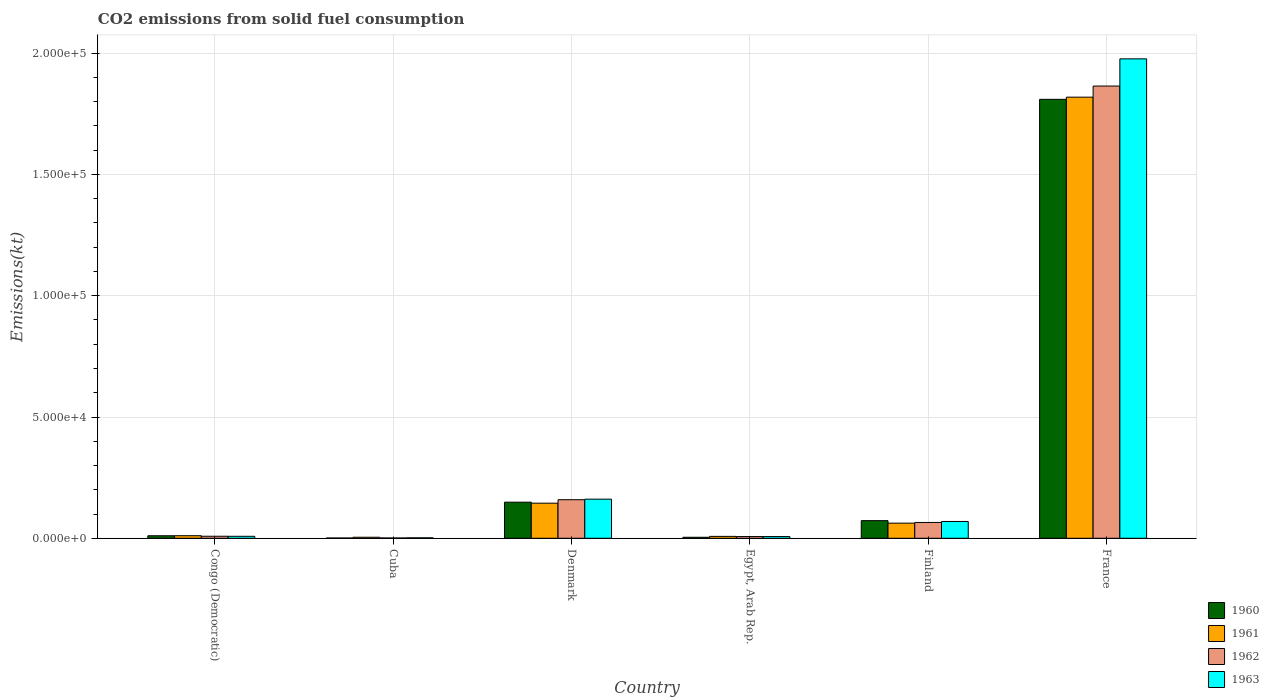How many different coloured bars are there?
Offer a very short reply. 4. How many groups of bars are there?
Give a very brief answer. 6. Are the number of bars per tick equal to the number of legend labels?
Your response must be concise. Yes. What is the amount of CO2 emitted in 1963 in France?
Your answer should be compact. 1.98e+05. Across all countries, what is the maximum amount of CO2 emitted in 1960?
Your answer should be very brief. 1.81e+05. Across all countries, what is the minimum amount of CO2 emitted in 1960?
Keep it short and to the point. 113.68. In which country was the amount of CO2 emitted in 1963 minimum?
Keep it short and to the point. Cuba. What is the total amount of CO2 emitted in 1960 in the graph?
Provide a succinct answer. 2.05e+05. What is the difference between the amount of CO2 emitted in 1963 in Cuba and that in Finland?
Your response must be concise. -6739.95. What is the difference between the amount of CO2 emitted in 1960 in France and the amount of CO2 emitted in 1961 in Finland?
Offer a terse response. 1.75e+05. What is the average amount of CO2 emitted in 1960 per country?
Keep it short and to the point. 3.41e+04. What is the difference between the amount of CO2 emitted of/in 1960 and amount of CO2 emitted of/in 1963 in Finland?
Your answer should be very brief. 341.03. In how many countries, is the amount of CO2 emitted in 1962 greater than 180000 kt?
Offer a terse response. 1. What is the ratio of the amount of CO2 emitted in 1961 in Finland to that in France?
Provide a short and direct response. 0.03. Is the difference between the amount of CO2 emitted in 1960 in Egypt, Arab Rep. and Finland greater than the difference between the amount of CO2 emitted in 1963 in Egypt, Arab Rep. and Finland?
Your answer should be very brief. No. What is the difference between the highest and the second highest amount of CO2 emitted in 1962?
Your response must be concise. 1.80e+05. What is the difference between the highest and the lowest amount of CO2 emitted in 1963?
Your response must be concise. 1.97e+05. Is the sum of the amount of CO2 emitted in 1960 in Egypt, Arab Rep. and Finland greater than the maximum amount of CO2 emitted in 1961 across all countries?
Ensure brevity in your answer.  No. Is it the case that in every country, the sum of the amount of CO2 emitted in 1961 and amount of CO2 emitted in 1962 is greater than the sum of amount of CO2 emitted in 1960 and amount of CO2 emitted in 1963?
Ensure brevity in your answer.  No. Is it the case that in every country, the sum of the amount of CO2 emitted in 1961 and amount of CO2 emitted in 1963 is greater than the amount of CO2 emitted in 1962?
Your answer should be compact. Yes. How many bars are there?
Keep it short and to the point. 24. Are all the bars in the graph horizontal?
Give a very brief answer. No. How many countries are there in the graph?
Your response must be concise. 6. What is the difference between two consecutive major ticks on the Y-axis?
Offer a very short reply. 5.00e+04. Are the values on the major ticks of Y-axis written in scientific E-notation?
Give a very brief answer. Yes. Where does the legend appear in the graph?
Provide a succinct answer. Bottom right. How many legend labels are there?
Ensure brevity in your answer.  4. What is the title of the graph?
Provide a short and direct response. CO2 emissions from solid fuel consumption. Does "2008" appear as one of the legend labels in the graph?
Keep it short and to the point. No. What is the label or title of the X-axis?
Make the answer very short. Country. What is the label or title of the Y-axis?
Keep it short and to the point. Emissions(kt). What is the Emissions(kt) of 1960 in Congo (Democratic)?
Provide a succinct answer. 1041.43. What is the Emissions(kt) in 1961 in Congo (Democratic)?
Provide a short and direct response. 1059.76. What is the Emissions(kt) of 1962 in Congo (Democratic)?
Make the answer very short. 839.74. What is the Emissions(kt) in 1963 in Congo (Democratic)?
Your response must be concise. 817.74. What is the Emissions(kt) in 1960 in Cuba?
Your answer should be very brief. 113.68. What is the Emissions(kt) of 1961 in Cuba?
Your answer should be very brief. 425.37. What is the Emissions(kt) of 1962 in Cuba?
Provide a short and direct response. 124.68. What is the Emissions(kt) in 1963 in Cuba?
Your answer should be compact. 187.02. What is the Emissions(kt) in 1960 in Denmark?
Give a very brief answer. 1.49e+04. What is the Emissions(kt) in 1961 in Denmark?
Provide a succinct answer. 1.45e+04. What is the Emissions(kt) in 1962 in Denmark?
Provide a short and direct response. 1.59e+04. What is the Emissions(kt) of 1963 in Denmark?
Keep it short and to the point. 1.61e+04. What is the Emissions(kt) in 1960 in Egypt, Arab Rep.?
Your answer should be compact. 414.37. What is the Emissions(kt) of 1961 in Egypt, Arab Rep.?
Make the answer very short. 781.07. What is the Emissions(kt) in 1962 in Egypt, Arab Rep.?
Keep it short and to the point. 707.73. What is the Emissions(kt) of 1963 in Egypt, Arab Rep.?
Provide a succinct answer. 707.73. What is the Emissions(kt) of 1960 in Finland?
Your answer should be very brief. 7267.99. What is the Emissions(kt) in 1961 in Finland?
Your response must be concise. 6237.57. What is the Emissions(kt) of 1962 in Finland?
Your answer should be very brief. 6523.59. What is the Emissions(kt) in 1963 in Finland?
Offer a terse response. 6926.96. What is the Emissions(kt) in 1960 in France?
Your response must be concise. 1.81e+05. What is the Emissions(kt) in 1961 in France?
Offer a terse response. 1.82e+05. What is the Emissions(kt) of 1962 in France?
Your answer should be very brief. 1.86e+05. What is the Emissions(kt) of 1963 in France?
Keep it short and to the point. 1.98e+05. Across all countries, what is the maximum Emissions(kt) in 1960?
Provide a short and direct response. 1.81e+05. Across all countries, what is the maximum Emissions(kt) in 1961?
Your answer should be very brief. 1.82e+05. Across all countries, what is the maximum Emissions(kt) of 1962?
Offer a terse response. 1.86e+05. Across all countries, what is the maximum Emissions(kt) in 1963?
Make the answer very short. 1.98e+05. Across all countries, what is the minimum Emissions(kt) of 1960?
Your answer should be very brief. 113.68. Across all countries, what is the minimum Emissions(kt) of 1961?
Provide a short and direct response. 425.37. Across all countries, what is the minimum Emissions(kt) in 1962?
Provide a short and direct response. 124.68. Across all countries, what is the minimum Emissions(kt) of 1963?
Provide a short and direct response. 187.02. What is the total Emissions(kt) in 1960 in the graph?
Provide a succinct answer. 2.05e+05. What is the total Emissions(kt) of 1961 in the graph?
Ensure brevity in your answer.  2.05e+05. What is the total Emissions(kt) of 1962 in the graph?
Your response must be concise. 2.11e+05. What is the total Emissions(kt) of 1963 in the graph?
Offer a very short reply. 2.22e+05. What is the difference between the Emissions(kt) of 1960 in Congo (Democratic) and that in Cuba?
Give a very brief answer. 927.75. What is the difference between the Emissions(kt) in 1961 in Congo (Democratic) and that in Cuba?
Your answer should be very brief. 634.39. What is the difference between the Emissions(kt) of 1962 in Congo (Democratic) and that in Cuba?
Offer a terse response. 715.07. What is the difference between the Emissions(kt) of 1963 in Congo (Democratic) and that in Cuba?
Give a very brief answer. 630.72. What is the difference between the Emissions(kt) in 1960 in Congo (Democratic) and that in Denmark?
Offer a terse response. -1.38e+04. What is the difference between the Emissions(kt) in 1961 in Congo (Democratic) and that in Denmark?
Your answer should be very brief. -1.34e+04. What is the difference between the Emissions(kt) of 1962 in Congo (Democratic) and that in Denmark?
Ensure brevity in your answer.  -1.51e+04. What is the difference between the Emissions(kt) in 1963 in Congo (Democratic) and that in Denmark?
Provide a succinct answer. -1.53e+04. What is the difference between the Emissions(kt) of 1960 in Congo (Democratic) and that in Egypt, Arab Rep.?
Offer a very short reply. 627.06. What is the difference between the Emissions(kt) of 1961 in Congo (Democratic) and that in Egypt, Arab Rep.?
Your response must be concise. 278.69. What is the difference between the Emissions(kt) in 1962 in Congo (Democratic) and that in Egypt, Arab Rep.?
Your answer should be compact. 132.01. What is the difference between the Emissions(kt) in 1963 in Congo (Democratic) and that in Egypt, Arab Rep.?
Your response must be concise. 110.01. What is the difference between the Emissions(kt) of 1960 in Congo (Democratic) and that in Finland?
Your response must be concise. -6226.57. What is the difference between the Emissions(kt) in 1961 in Congo (Democratic) and that in Finland?
Offer a terse response. -5177.8. What is the difference between the Emissions(kt) of 1962 in Congo (Democratic) and that in Finland?
Offer a terse response. -5683.85. What is the difference between the Emissions(kt) in 1963 in Congo (Democratic) and that in Finland?
Offer a terse response. -6109.22. What is the difference between the Emissions(kt) of 1960 in Congo (Democratic) and that in France?
Give a very brief answer. -1.80e+05. What is the difference between the Emissions(kt) of 1961 in Congo (Democratic) and that in France?
Provide a short and direct response. -1.81e+05. What is the difference between the Emissions(kt) of 1962 in Congo (Democratic) and that in France?
Keep it short and to the point. -1.86e+05. What is the difference between the Emissions(kt) in 1963 in Congo (Democratic) and that in France?
Ensure brevity in your answer.  -1.97e+05. What is the difference between the Emissions(kt) in 1960 in Cuba and that in Denmark?
Give a very brief answer. -1.48e+04. What is the difference between the Emissions(kt) in 1961 in Cuba and that in Denmark?
Your response must be concise. -1.40e+04. What is the difference between the Emissions(kt) in 1962 in Cuba and that in Denmark?
Offer a very short reply. -1.58e+04. What is the difference between the Emissions(kt) of 1963 in Cuba and that in Denmark?
Your answer should be very brief. -1.59e+04. What is the difference between the Emissions(kt) in 1960 in Cuba and that in Egypt, Arab Rep.?
Ensure brevity in your answer.  -300.69. What is the difference between the Emissions(kt) in 1961 in Cuba and that in Egypt, Arab Rep.?
Offer a very short reply. -355.7. What is the difference between the Emissions(kt) in 1962 in Cuba and that in Egypt, Arab Rep.?
Ensure brevity in your answer.  -583.05. What is the difference between the Emissions(kt) of 1963 in Cuba and that in Egypt, Arab Rep.?
Give a very brief answer. -520.71. What is the difference between the Emissions(kt) of 1960 in Cuba and that in Finland?
Ensure brevity in your answer.  -7154.32. What is the difference between the Emissions(kt) in 1961 in Cuba and that in Finland?
Make the answer very short. -5812.19. What is the difference between the Emissions(kt) of 1962 in Cuba and that in Finland?
Your answer should be compact. -6398.91. What is the difference between the Emissions(kt) in 1963 in Cuba and that in Finland?
Give a very brief answer. -6739.95. What is the difference between the Emissions(kt) in 1960 in Cuba and that in France?
Keep it short and to the point. -1.81e+05. What is the difference between the Emissions(kt) in 1961 in Cuba and that in France?
Offer a terse response. -1.81e+05. What is the difference between the Emissions(kt) of 1962 in Cuba and that in France?
Keep it short and to the point. -1.86e+05. What is the difference between the Emissions(kt) in 1963 in Cuba and that in France?
Your response must be concise. -1.97e+05. What is the difference between the Emissions(kt) of 1960 in Denmark and that in Egypt, Arab Rep.?
Keep it short and to the point. 1.45e+04. What is the difference between the Emissions(kt) of 1961 in Denmark and that in Egypt, Arab Rep.?
Your response must be concise. 1.37e+04. What is the difference between the Emissions(kt) in 1962 in Denmark and that in Egypt, Arab Rep.?
Make the answer very short. 1.52e+04. What is the difference between the Emissions(kt) of 1963 in Denmark and that in Egypt, Arab Rep.?
Offer a terse response. 1.54e+04. What is the difference between the Emissions(kt) in 1960 in Denmark and that in Finland?
Offer a terse response. 7620.03. What is the difference between the Emissions(kt) of 1961 in Denmark and that in Finland?
Provide a succinct answer. 8232.42. What is the difference between the Emissions(kt) in 1962 in Denmark and that in Finland?
Keep it short and to the point. 9380.19. What is the difference between the Emissions(kt) of 1963 in Denmark and that in Finland?
Make the answer very short. 9204.17. What is the difference between the Emissions(kt) of 1960 in Denmark and that in France?
Provide a succinct answer. -1.66e+05. What is the difference between the Emissions(kt) in 1961 in Denmark and that in France?
Make the answer very short. -1.67e+05. What is the difference between the Emissions(kt) in 1962 in Denmark and that in France?
Offer a very short reply. -1.71e+05. What is the difference between the Emissions(kt) in 1963 in Denmark and that in France?
Your response must be concise. -1.82e+05. What is the difference between the Emissions(kt) of 1960 in Egypt, Arab Rep. and that in Finland?
Offer a very short reply. -6853.62. What is the difference between the Emissions(kt) of 1961 in Egypt, Arab Rep. and that in Finland?
Your answer should be compact. -5456.5. What is the difference between the Emissions(kt) of 1962 in Egypt, Arab Rep. and that in Finland?
Offer a very short reply. -5815.86. What is the difference between the Emissions(kt) of 1963 in Egypt, Arab Rep. and that in Finland?
Give a very brief answer. -6219.23. What is the difference between the Emissions(kt) in 1960 in Egypt, Arab Rep. and that in France?
Your answer should be compact. -1.81e+05. What is the difference between the Emissions(kt) of 1961 in Egypt, Arab Rep. and that in France?
Offer a terse response. -1.81e+05. What is the difference between the Emissions(kt) in 1962 in Egypt, Arab Rep. and that in France?
Give a very brief answer. -1.86e+05. What is the difference between the Emissions(kt) in 1963 in Egypt, Arab Rep. and that in France?
Make the answer very short. -1.97e+05. What is the difference between the Emissions(kt) in 1960 in Finland and that in France?
Your answer should be very brief. -1.74e+05. What is the difference between the Emissions(kt) of 1961 in Finland and that in France?
Offer a terse response. -1.76e+05. What is the difference between the Emissions(kt) in 1962 in Finland and that in France?
Make the answer very short. -1.80e+05. What is the difference between the Emissions(kt) in 1963 in Finland and that in France?
Offer a very short reply. -1.91e+05. What is the difference between the Emissions(kt) in 1960 in Congo (Democratic) and the Emissions(kt) in 1961 in Cuba?
Keep it short and to the point. 616.06. What is the difference between the Emissions(kt) in 1960 in Congo (Democratic) and the Emissions(kt) in 1962 in Cuba?
Ensure brevity in your answer.  916.75. What is the difference between the Emissions(kt) of 1960 in Congo (Democratic) and the Emissions(kt) of 1963 in Cuba?
Ensure brevity in your answer.  854.41. What is the difference between the Emissions(kt) in 1961 in Congo (Democratic) and the Emissions(kt) in 1962 in Cuba?
Keep it short and to the point. 935.09. What is the difference between the Emissions(kt) in 1961 in Congo (Democratic) and the Emissions(kt) in 1963 in Cuba?
Provide a succinct answer. 872.75. What is the difference between the Emissions(kt) of 1962 in Congo (Democratic) and the Emissions(kt) of 1963 in Cuba?
Your response must be concise. 652.73. What is the difference between the Emissions(kt) of 1960 in Congo (Democratic) and the Emissions(kt) of 1961 in Denmark?
Make the answer very short. -1.34e+04. What is the difference between the Emissions(kt) in 1960 in Congo (Democratic) and the Emissions(kt) in 1962 in Denmark?
Provide a short and direct response. -1.49e+04. What is the difference between the Emissions(kt) in 1960 in Congo (Democratic) and the Emissions(kt) in 1963 in Denmark?
Keep it short and to the point. -1.51e+04. What is the difference between the Emissions(kt) in 1961 in Congo (Democratic) and the Emissions(kt) in 1962 in Denmark?
Offer a very short reply. -1.48e+04. What is the difference between the Emissions(kt) of 1961 in Congo (Democratic) and the Emissions(kt) of 1963 in Denmark?
Provide a succinct answer. -1.51e+04. What is the difference between the Emissions(kt) in 1962 in Congo (Democratic) and the Emissions(kt) in 1963 in Denmark?
Make the answer very short. -1.53e+04. What is the difference between the Emissions(kt) of 1960 in Congo (Democratic) and the Emissions(kt) of 1961 in Egypt, Arab Rep.?
Provide a short and direct response. 260.36. What is the difference between the Emissions(kt) in 1960 in Congo (Democratic) and the Emissions(kt) in 1962 in Egypt, Arab Rep.?
Offer a terse response. 333.7. What is the difference between the Emissions(kt) of 1960 in Congo (Democratic) and the Emissions(kt) of 1963 in Egypt, Arab Rep.?
Your answer should be compact. 333.7. What is the difference between the Emissions(kt) of 1961 in Congo (Democratic) and the Emissions(kt) of 1962 in Egypt, Arab Rep.?
Your answer should be very brief. 352.03. What is the difference between the Emissions(kt) in 1961 in Congo (Democratic) and the Emissions(kt) in 1963 in Egypt, Arab Rep.?
Give a very brief answer. 352.03. What is the difference between the Emissions(kt) of 1962 in Congo (Democratic) and the Emissions(kt) of 1963 in Egypt, Arab Rep.?
Keep it short and to the point. 132.01. What is the difference between the Emissions(kt) in 1960 in Congo (Democratic) and the Emissions(kt) in 1961 in Finland?
Provide a short and direct response. -5196.14. What is the difference between the Emissions(kt) in 1960 in Congo (Democratic) and the Emissions(kt) in 1962 in Finland?
Offer a terse response. -5482.16. What is the difference between the Emissions(kt) of 1960 in Congo (Democratic) and the Emissions(kt) of 1963 in Finland?
Your answer should be very brief. -5885.53. What is the difference between the Emissions(kt) in 1961 in Congo (Democratic) and the Emissions(kt) in 1962 in Finland?
Give a very brief answer. -5463.83. What is the difference between the Emissions(kt) of 1961 in Congo (Democratic) and the Emissions(kt) of 1963 in Finland?
Give a very brief answer. -5867.2. What is the difference between the Emissions(kt) of 1962 in Congo (Democratic) and the Emissions(kt) of 1963 in Finland?
Provide a short and direct response. -6087.22. What is the difference between the Emissions(kt) of 1960 in Congo (Democratic) and the Emissions(kt) of 1961 in France?
Keep it short and to the point. -1.81e+05. What is the difference between the Emissions(kt) of 1960 in Congo (Democratic) and the Emissions(kt) of 1962 in France?
Keep it short and to the point. -1.85e+05. What is the difference between the Emissions(kt) of 1960 in Congo (Democratic) and the Emissions(kt) of 1963 in France?
Make the answer very short. -1.97e+05. What is the difference between the Emissions(kt) of 1961 in Congo (Democratic) and the Emissions(kt) of 1962 in France?
Your response must be concise. -1.85e+05. What is the difference between the Emissions(kt) of 1961 in Congo (Democratic) and the Emissions(kt) of 1963 in France?
Your answer should be compact. -1.97e+05. What is the difference between the Emissions(kt) in 1962 in Congo (Democratic) and the Emissions(kt) in 1963 in France?
Provide a succinct answer. -1.97e+05. What is the difference between the Emissions(kt) in 1960 in Cuba and the Emissions(kt) in 1961 in Denmark?
Offer a very short reply. -1.44e+04. What is the difference between the Emissions(kt) in 1960 in Cuba and the Emissions(kt) in 1962 in Denmark?
Give a very brief answer. -1.58e+04. What is the difference between the Emissions(kt) in 1960 in Cuba and the Emissions(kt) in 1963 in Denmark?
Your response must be concise. -1.60e+04. What is the difference between the Emissions(kt) in 1961 in Cuba and the Emissions(kt) in 1962 in Denmark?
Make the answer very short. -1.55e+04. What is the difference between the Emissions(kt) of 1961 in Cuba and the Emissions(kt) of 1963 in Denmark?
Offer a very short reply. -1.57e+04. What is the difference between the Emissions(kt) in 1962 in Cuba and the Emissions(kt) in 1963 in Denmark?
Give a very brief answer. -1.60e+04. What is the difference between the Emissions(kt) of 1960 in Cuba and the Emissions(kt) of 1961 in Egypt, Arab Rep.?
Your answer should be very brief. -667.39. What is the difference between the Emissions(kt) of 1960 in Cuba and the Emissions(kt) of 1962 in Egypt, Arab Rep.?
Your answer should be compact. -594.05. What is the difference between the Emissions(kt) of 1960 in Cuba and the Emissions(kt) of 1963 in Egypt, Arab Rep.?
Your answer should be very brief. -594.05. What is the difference between the Emissions(kt) in 1961 in Cuba and the Emissions(kt) in 1962 in Egypt, Arab Rep.?
Your answer should be very brief. -282.36. What is the difference between the Emissions(kt) of 1961 in Cuba and the Emissions(kt) of 1963 in Egypt, Arab Rep.?
Your answer should be very brief. -282.36. What is the difference between the Emissions(kt) in 1962 in Cuba and the Emissions(kt) in 1963 in Egypt, Arab Rep.?
Offer a very short reply. -583.05. What is the difference between the Emissions(kt) of 1960 in Cuba and the Emissions(kt) of 1961 in Finland?
Ensure brevity in your answer.  -6123.89. What is the difference between the Emissions(kt) in 1960 in Cuba and the Emissions(kt) in 1962 in Finland?
Give a very brief answer. -6409.92. What is the difference between the Emissions(kt) of 1960 in Cuba and the Emissions(kt) of 1963 in Finland?
Provide a short and direct response. -6813.29. What is the difference between the Emissions(kt) of 1961 in Cuba and the Emissions(kt) of 1962 in Finland?
Ensure brevity in your answer.  -6098.22. What is the difference between the Emissions(kt) in 1961 in Cuba and the Emissions(kt) in 1963 in Finland?
Make the answer very short. -6501.59. What is the difference between the Emissions(kt) in 1962 in Cuba and the Emissions(kt) in 1963 in Finland?
Give a very brief answer. -6802.28. What is the difference between the Emissions(kt) of 1960 in Cuba and the Emissions(kt) of 1961 in France?
Keep it short and to the point. -1.82e+05. What is the difference between the Emissions(kt) of 1960 in Cuba and the Emissions(kt) of 1962 in France?
Provide a short and direct response. -1.86e+05. What is the difference between the Emissions(kt) in 1960 in Cuba and the Emissions(kt) in 1963 in France?
Your response must be concise. -1.98e+05. What is the difference between the Emissions(kt) of 1961 in Cuba and the Emissions(kt) of 1962 in France?
Keep it short and to the point. -1.86e+05. What is the difference between the Emissions(kt) of 1961 in Cuba and the Emissions(kt) of 1963 in France?
Your answer should be very brief. -1.97e+05. What is the difference between the Emissions(kt) of 1962 in Cuba and the Emissions(kt) of 1963 in France?
Provide a succinct answer. -1.98e+05. What is the difference between the Emissions(kt) of 1960 in Denmark and the Emissions(kt) of 1961 in Egypt, Arab Rep.?
Offer a terse response. 1.41e+04. What is the difference between the Emissions(kt) in 1960 in Denmark and the Emissions(kt) in 1962 in Egypt, Arab Rep.?
Offer a very short reply. 1.42e+04. What is the difference between the Emissions(kt) in 1960 in Denmark and the Emissions(kt) in 1963 in Egypt, Arab Rep.?
Give a very brief answer. 1.42e+04. What is the difference between the Emissions(kt) of 1961 in Denmark and the Emissions(kt) of 1962 in Egypt, Arab Rep.?
Provide a short and direct response. 1.38e+04. What is the difference between the Emissions(kt) in 1961 in Denmark and the Emissions(kt) in 1963 in Egypt, Arab Rep.?
Provide a short and direct response. 1.38e+04. What is the difference between the Emissions(kt) in 1962 in Denmark and the Emissions(kt) in 1963 in Egypt, Arab Rep.?
Give a very brief answer. 1.52e+04. What is the difference between the Emissions(kt) of 1960 in Denmark and the Emissions(kt) of 1961 in Finland?
Offer a very short reply. 8650.45. What is the difference between the Emissions(kt) in 1960 in Denmark and the Emissions(kt) in 1962 in Finland?
Your response must be concise. 8364.43. What is the difference between the Emissions(kt) in 1960 in Denmark and the Emissions(kt) in 1963 in Finland?
Ensure brevity in your answer.  7961.06. What is the difference between the Emissions(kt) of 1961 in Denmark and the Emissions(kt) of 1962 in Finland?
Give a very brief answer. 7946.39. What is the difference between the Emissions(kt) of 1961 in Denmark and the Emissions(kt) of 1963 in Finland?
Provide a short and direct response. 7543.02. What is the difference between the Emissions(kt) of 1962 in Denmark and the Emissions(kt) of 1963 in Finland?
Offer a very short reply. 8976.82. What is the difference between the Emissions(kt) in 1960 in Denmark and the Emissions(kt) in 1961 in France?
Make the answer very short. -1.67e+05. What is the difference between the Emissions(kt) in 1960 in Denmark and the Emissions(kt) in 1962 in France?
Provide a succinct answer. -1.72e+05. What is the difference between the Emissions(kt) in 1960 in Denmark and the Emissions(kt) in 1963 in France?
Your answer should be very brief. -1.83e+05. What is the difference between the Emissions(kt) in 1961 in Denmark and the Emissions(kt) in 1962 in France?
Offer a terse response. -1.72e+05. What is the difference between the Emissions(kt) in 1961 in Denmark and the Emissions(kt) in 1963 in France?
Keep it short and to the point. -1.83e+05. What is the difference between the Emissions(kt) in 1962 in Denmark and the Emissions(kt) in 1963 in France?
Offer a terse response. -1.82e+05. What is the difference between the Emissions(kt) in 1960 in Egypt, Arab Rep. and the Emissions(kt) in 1961 in Finland?
Provide a succinct answer. -5823.2. What is the difference between the Emissions(kt) in 1960 in Egypt, Arab Rep. and the Emissions(kt) in 1962 in Finland?
Your response must be concise. -6109.22. What is the difference between the Emissions(kt) in 1960 in Egypt, Arab Rep. and the Emissions(kt) in 1963 in Finland?
Make the answer very short. -6512.59. What is the difference between the Emissions(kt) in 1961 in Egypt, Arab Rep. and the Emissions(kt) in 1962 in Finland?
Make the answer very short. -5742.52. What is the difference between the Emissions(kt) in 1961 in Egypt, Arab Rep. and the Emissions(kt) in 1963 in Finland?
Your answer should be very brief. -6145.89. What is the difference between the Emissions(kt) of 1962 in Egypt, Arab Rep. and the Emissions(kt) of 1963 in Finland?
Offer a very short reply. -6219.23. What is the difference between the Emissions(kt) of 1960 in Egypt, Arab Rep. and the Emissions(kt) of 1961 in France?
Provide a succinct answer. -1.81e+05. What is the difference between the Emissions(kt) in 1960 in Egypt, Arab Rep. and the Emissions(kt) in 1962 in France?
Provide a succinct answer. -1.86e+05. What is the difference between the Emissions(kt) in 1960 in Egypt, Arab Rep. and the Emissions(kt) in 1963 in France?
Your answer should be very brief. -1.97e+05. What is the difference between the Emissions(kt) of 1961 in Egypt, Arab Rep. and the Emissions(kt) of 1962 in France?
Provide a succinct answer. -1.86e+05. What is the difference between the Emissions(kt) in 1961 in Egypt, Arab Rep. and the Emissions(kt) in 1963 in France?
Make the answer very short. -1.97e+05. What is the difference between the Emissions(kt) of 1962 in Egypt, Arab Rep. and the Emissions(kt) of 1963 in France?
Ensure brevity in your answer.  -1.97e+05. What is the difference between the Emissions(kt) in 1960 in Finland and the Emissions(kt) in 1961 in France?
Your answer should be compact. -1.75e+05. What is the difference between the Emissions(kt) of 1960 in Finland and the Emissions(kt) of 1962 in France?
Your answer should be compact. -1.79e+05. What is the difference between the Emissions(kt) in 1960 in Finland and the Emissions(kt) in 1963 in France?
Keep it short and to the point. -1.90e+05. What is the difference between the Emissions(kt) in 1961 in Finland and the Emissions(kt) in 1962 in France?
Your answer should be very brief. -1.80e+05. What is the difference between the Emissions(kt) in 1961 in Finland and the Emissions(kt) in 1963 in France?
Provide a succinct answer. -1.91e+05. What is the difference between the Emissions(kt) in 1962 in Finland and the Emissions(kt) in 1963 in France?
Give a very brief answer. -1.91e+05. What is the average Emissions(kt) in 1960 per country?
Give a very brief answer. 3.41e+04. What is the average Emissions(kt) of 1961 per country?
Your response must be concise. 3.41e+04. What is the average Emissions(kt) of 1962 per country?
Make the answer very short. 3.51e+04. What is the average Emissions(kt) of 1963 per country?
Give a very brief answer. 3.71e+04. What is the difference between the Emissions(kt) in 1960 and Emissions(kt) in 1961 in Congo (Democratic)?
Keep it short and to the point. -18.34. What is the difference between the Emissions(kt) of 1960 and Emissions(kt) of 1962 in Congo (Democratic)?
Your answer should be very brief. 201.69. What is the difference between the Emissions(kt) in 1960 and Emissions(kt) in 1963 in Congo (Democratic)?
Keep it short and to the point. 223.69. What is the difference between the Emissions(kt) of 1961 and Emissions(kt) of 1962 in Congo (Democratic)?
Offer a very short reply. 220.02. What is the difference between the Emissions(kt) in 1961 and Emissions(kt) in 1963 in Congo (Democratic)?
Your answer should be very brief. 242.02. What is the difference between the Emissions(kt) in 1962 and Emissions(kt) in 1963 in Congo (Democratic)?
Your answer should be compact. 22. What is the difference between the Emissions(kt) of 1960 and Emissions(kt) of 1961 in Cuba?
Ensure brevity in your answer.  -311.69. What is the difference between the Emissions(kt) of 1960 and Emissions(kt) of 1962 in Cuba?
Ensure brevity in your answer.  -11. What is the difference between the Emissions(kt) of 1960 and Emissions(kt) of 1963 in Cuba?
Your response must be concise. -73.34. What is the difference between the Emissions(kt) in 1961 and Emissions(kt) in 1962 in Cuba?
Your answer should be compact. 300.69. What is the difference between the Emissions(kt) of 1961 and Emissions(kt) of 1963 in Cuba?
Provide a short and direct response. 238.35. What is the difference between the Emissions(kt) of 1962 and Emissions(kt) of 1963 in Cuba?
Your response must be concise. -62.34. What is the difference between the Emissions(kt) in 1960 and Emissions(kt) in 1961 in Denmark?
Ensure brevity in your answer.  418.04. What is the difference between the Emissions(kt) in 1960 and Emissions(kt) in 1962 in Denmark?
Give a very brief answer. -1015.76. What is the difference between the Emissions(kt) in 1960 and Emissions(kt) in 1963 in Denmark?
Offer a terse response. -1243.11. What is the difference between the Emissions(kt) in 1961 and Emissions(kt) in 1962 in Denmark?
Make the answer very short. -1433.8. What is the difference between the Emissions(kt) in 1961 and Emissions(kt) in 1963 in Denmark?
Offer a terse response. -1661.15. What is the difference between the Emissions(kt) of 1962 and Emissions(kt) of 1963 in Denmark?
Your answer should be compact. -227.35. What is the difference between the Emissions(kt) in 1960 and Emissions(kt) in 1961 in Egypt, Arab Rep.?
Ensure brevity in your answer.  -366.7. What is the difference between the Emissions(kt) of 1960 and Emissions(kt) of 1962 in Egypt, Arab Rep.?
Offer a very short reply. -293.36. What is the difference between the Emissions(kt) of 1960 and Emissions(kt) of 1963 in Egypt, Arab Rep.?
Offer a very short reply. -293.36. What is the difference between the Emissions(kt) of 1961 and Emissions(kt) of 1962 in Egypt, Arab Rep.?
Your answer should be compact. 73.34. What is the difference between the Emissions(kt) of 1961 and Emissions(kt) of 1963 in Egypt, Arab Rep.?
Make the answer very short. 73.34. What is the difference between the Emissions(kt) of 1960 and Emissions(kt) of 1961 in Finland?
Give a very brief answer. 1030.43. What is the difference between the Emissions(kt) in 1960 and Emissions(kt) in 1962 in Finland?
Offer a terse response. 744.4. What is the difference between the Emissions(kt) of 1960 and Emissions(kt) of 1963 in Finland?
Make the answer very short. 341.03. What is the difference between the Emissions(kt) of 1961 and Emissions(kt) of 1962 in Finland?
Provide a succinct answer. -286.03. What is the difference between the Emissions(kt) of 1961 and Emissions(kt) of 1963 in Finland?
Keep it short and to the point. -689.4. What is the difference between the Emissions(kt) of 1962 and Emissions(kt) of 1963 in Finland?
Make the answer very short. -403.37. What is the difference between the Emissions(kt) of 1960 and Emissions(kt) of 1961 in France?
Provide a succinct answer. -887.41. What is the difference between the Emissions(kt) of 1960 and Emissions(kt) of 1962 in France?
Provide a short and direct response. -5471.16. What is the difference between the Emissions(kt) in 1960 and Emissions(kt) in 1963 in France?
Ensure brevity in your answer.  -1.67e+04. What is the difference between the Emissions(kt) of 1961 and Emissions(kt) of 1962 in France?
Provide a succinct answer. -4583.75. What is the difference between the Emissions(kt) in 1961 and Emissions(kt) in 1963 in France?
Your response must be concise. -1.58e+04. What is the difference between the Emissions(kt) in 1962 and Emissions(kt) in 1963 in France?
Your answer should be very brief. -1.12e+04. What is the ratio of the Emissions(kt) of 1960 in Congo (Democratic) to that in Cuba?
Make the answer very short. 9.16. What is the ratio of the Emissions(kt) of 1961 in Congo (Democratic) to that in Cuba?
Offer a terse response. 2.49. What is the ratio of the Emissions(kt) of 1962 in Congo (Democratic) to that in Cuba?
Your response must be concise. 6.74. What is the ratio of the Emissions(kt) in 1963 in Congo (Democratic) to that in Cuba?
Make the answer very short. 4.37. What is the ratio of the Emissions(kt) in 1960 in Congo (Democratic) to that in Denmark?
Keep it short and to the point. 0.07. What is the ratio of the Emissions(kt) of 1961 in Congo (Democratic) to that in Denmark?
Offer a terse response. 0.07. What is the ratio of the Emissions(kt) of 1962 in Congo (Democratic) to that in Denmark?
Provide a short and direct response. 0.05. What is the ratio of the Emissions(kt) of 1963 in Congo (Democratic) to that in Denmark?
Offer a very short reply. 0.05. What is the ratio of the Emissions(kt) in 1960 in Congo (Democratic) to that in Egypt, Arab Rep.?
Keep it short and to the point. 2.51. What is the ratio of the Emissions(kt) of 1961 in Congo (Democratic) to that in Egypt, Arab Rep.?
Offer a very short reply. 1.36. What is the ratio of the Emissions(kt) of 1962 in Congo (Democratic) to that in Egypt, Arab Rep.?
Your answer should be very brief. 1.19. What is the ratio of the Emissions(kt) of 1963 in Congo (Democratic) to that in Egypt, Arab Rep.?
Offer a terse response. 1.16. What is the ratio of the Emissions(kt) in 1960 in Congo (Democratic) to that in Finland?
Provide a short and direct response. 0.14. What is the ratio of the Emissions(kt) of 1961 in Congo (Democratic) to that in Finland?
Ensure brevity in your answer.  0.17. What is the ratio of the Emissions(kt) of 1962 in Congo (Democratic) to that in Finland?
Give a very brief answer. 0.13. What is the ratio of the Emissions(kt) in 1963 in Congo (Democratic) to that in Finland?
Your response must be concise. 0.12. What is the ratio of the Emissions(kt) of 1960 in Congo (Democratic) to that in France?
Your answer should be very brief. 0.01. What is the ratio of the Emissions(kt) in 1961 in Congo (Democratic) to that in France?
Your answer should be compact. 0.01. What is the ratio of the Emissions(kt) in 1962 in Congo (Democratic) to that in France?
Your response must be concise. 0. What is the ratio of the Emissions(kt) of 1963 in Congo (Democratic) to that in France?
Ensure brevity in your answer.  0. What is the ratio of the Emissions(kt) in 1960 in Cuba to that in Denmark?
Your answer should be compact. 0.01. What is the ratio of the Emissions(kt) in 1961 in Cuba to that in Denmark?
Make the answer very short. 0.03. What is the ratio of the Emissions(kt) in 1962 in Cuba to that in Denmark?
Your response must be concise. 0.01. What is the ratio of the Emissions(kt) in 1963 in Cuba to that in Denmark?
Offer a terse response. 0.01. What is the ratio of the Emissions(kt) of 1960 in Cuba to that in Egypt, Arab Rep.?
Give a very brief answer. 0.27. What is the ratio of the Emissions(kt) of 1961 in Cuba to that in Egypt, Arab Rep.?
Make the answer very short. 0.54. What is the ratio of the Emissions(kt) of 1962 in Cuba to that in Egypt, Arab Rep.?
Ensure brevity in your answer.  0.18. What is the ratio of the Emissions(kt) in 1963 in Cuba to that in Egypt, Arab Rep.?
Your answer should be very brief. 0.26. What is the ratio of the Emissions(kt) of 1960 in Cuba to that in Finland?
Give a very brief answer. 0.02. What is the ratio of the Emissions(kt) in 1961 in Cuba to that in Finland?
Provide a succinct answer. 0.07. What is the ratio of the Emissions(kt) in 1962 in Cuba to that in Finland?
Provide a short and direct response. 0.02. What is the ratio of the Emissions(kt) in 1963 in Cuba to that in Finland?
Provide a short and direct response. 0.03. What is the ratio of the Emissions(kt) in 1960 in Cuba to that in France?
Offer a terse response. 0. What is the ratio of the Emissions(kt) of 1961 in Cuba to that in France?
Provide a short and direct response. 0. What is the ratio of the Emissions(kt) in 1962 in Cuba to that in France?
Provide a short and direct response. 0. What is the ratio of the Emissions(kt) in 1963 in Cuba to that in France?
Give a very brief answer. 0. What is the ratio of the Emissions(kt) in 1960 in Denmark to that in Egypt, Arab Rep.?
Your answer should be compact. 35.93. What is the ratio of the Emissions(kt) of 1961 in Denmark to that in Egypt, Arab Rep.?
Give a very brief answer. 18.53. What is the ratio of the Emissions(kt) in 1962 in Denmark to that in Egypt, Arab Rep.?
Your answer should be very brief. 22.47. What is the ratio of the Emissions(kt) in 1963 in Denmark to that in Egypt, Arab Rep.?
Your answer should be compact. 22.79. What is the ratio of the Emissions(kt) in 1960 in Denmark to that in Finland?
Give a very brief answer. 2.05. What is the ratio of the Emissions(kt) of 1961 in Denmark to that in Finland?
Ensure brevity in your answer.  2.32. What is the ratio of the Emissions(kt) of 1962 in Denmark to that in Finland?
Your answer should be compact. 2.44. What is the ratio of the Emissions(kt) in 1963 in Denmark to that in Finland?
Offer a terse response. 2.33. What is the ratio of the Emissions(kt) of 1960 in Denmark to that in France?
Your response must be concise. 0.08. What is the ratio of the Emissions(kt) in 1961 in Denmark to that in France?
Provide a short and direct response. 0.08. What is the ratio of the Emissions(kt) of 1962 in Denmark to that in France?
Your answer should be compact. 0.09. What is the ratio of the Emissions(kt) of 1963 in Denmark to that in France?
Offer a very short reply. 0.08. What is the ratio of the Emissions(kt) in 1960 in Egypt, Arab Rep. to that in Finland?
Provide a short and direct response. 0.06. What is the ratio of the Emissions(kt) in 1961 in Egypt, Arab Rep. to that in Finland?
Give a very brief answer. 0.13. What is the ratio of the Emissions(kt) in 1962 in Egypt, Arab Rep. to that in Finland?
Provide a succinct answer. 0.11. What is the ratio of the Emissions(kt) in 1963 in Egypt, Arab Rep. to that in Finland?
Make the answer very short. 0.1. What is the ratio of the Emissions(kt) in 1960 in Egypt, Arab Rep. to that in France?
Give a very brief answer. 0. What is the ratio of the Emissions(kt) in 1961 in Egypt, Arab Rep. to that in France?
Give a very brief answer. 0. What is the ratio of the Emissions(kt) in 1962 in Egypt, Arab Rep. to that in France?
Your answer should be very brief. 0. What is the ratio of the Emissions(kt) of 1963 in Egypt, Arab Rep. to that in France?
Make the answer very short. 0. What is the ratio of the Emissions(kt) of 1960 in Finland to that in France?
Ensure brevity in your answer.  0.04. What is the ratio of the Emissions(kt) of 1961 in Finland to that in France?
Offer a very short reply. 0.03. What is the ratio of the Emissions(kt) in 1962 in Finland to that in France?
Provide a succinct answer. 0.04. What is the ratio of the Emissions(kt) in 1963 in Finland to that in France?
Make the answer very short. 0.04. What is the difference between the highest and the second highest Emissions(kt) of 1960?
Keep it short and to the point. 1.66e+05. What is the difference between the highest and the second highest Emissions(kt) of 1961?
Your answer should be compact. 1.67e+05. What is the difference between the highest and the second highest Emissions(kt) in 1962?
Offer a very short reply. 1.71e+05. What is the difference between the highest and the second highest Emissions(kt) of 1963?
Ensure brevity in your answer.  1.82e+05. What is the difference between the highest and the lowest Emissions(kt) of 1960?
Your response must be concise. 1.81e+05. What is the difference between the highest and the lowest Emissions(kt) of 1961?
Make the answer very short. 1.81e+05. What is the difference between the highest and the lowest Emissions(kt) of 1962?
Your response must be concise. 1.86e+05. What is the difference between the highest and the lowest Emissions(kt) in 1963?
Your response must be concise. 1.97e+05. 